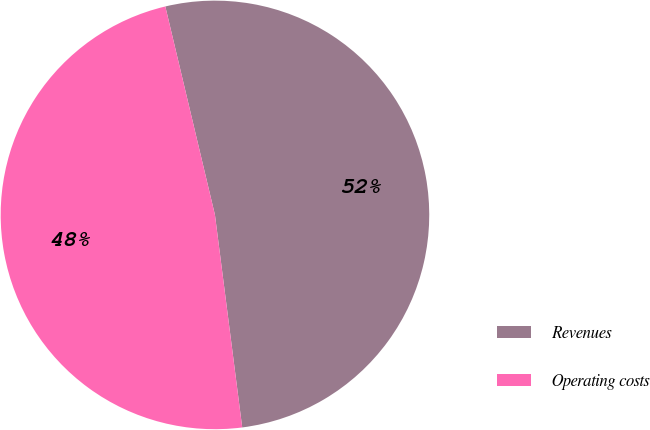<chart> <loc_0><loc_0><loc_500><loc_500><pie_chart><fcel>Revenues<fcel>Operating costs<nl><fcel>51.69%<fcel>48.31%<nl></chart> 